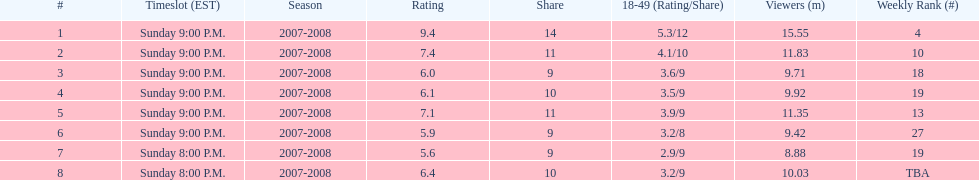When was the air date with the smallest audience? April 13, 2008. Write the full table. {'header': ['#', 'Timeslot (EST)', 'Season', 'Rating', 'Share', '18-49 (Rating/Share)', 'Viewers (m)', 'Weekly Rank (#)'], 'rows': [['1', 'Sunday 9:00 P.M.', '2007-2008', '9.4', '14', '5.3/12', '15.55', '4'], ['2', 'Sunday 9:00 P.M.', '2007-2008', '7.4', '11', '4.1/10', '11.83', '10'], ['3', 'Sunday 9:00 P.M.', '2007-2008', '6.0', '9', '3.6/9', '9.71', '18'], ['4', 'Sunday 9:00 P.M.', '2007-2008', '6.1', '10', '3.5/9', '9.92', '19'], ['5', 'Sunday 9:00 P.M.', '2007-2008', '7.1', '11', '3.9/9', '11.35', '13'], ['6', 'Sunday 9:00 P.M.', '2007-2008', '5.9', '9', '3.2/8', '9.42', '27'], ['7', 'Sunday 8:00 P.M.', '2007-2008', '5.6', '9', '2.9/9', '8.88', '19'], ['8', 'Sunday 8:00 P.M.', '2007-2008', '6.4', '10', '3.2/9', '10.03', 'TBA']]} 